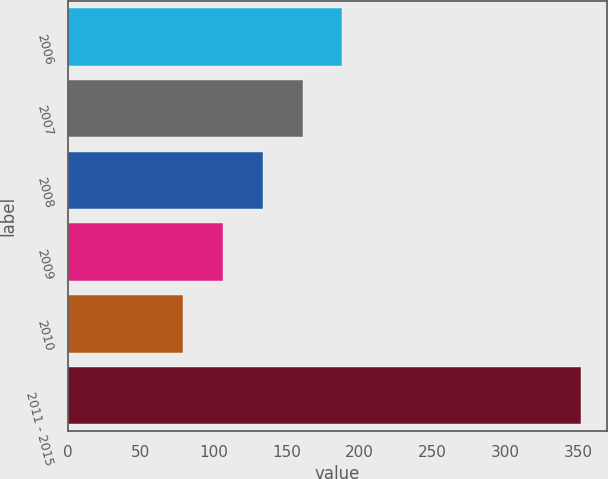Convert chart. <chart><loc_0><loc_0><loc_500><loc_500><bar_chart><fcel>2006<fcel>2007<fcel>2008<fcel>2009<fcel>2010<fcel>2011 - 2015<nl><fcel>188.2<fcel>160.9<fcel>133.6<fcel>106.3<fcel>79<fcel>352<nl></chart> 